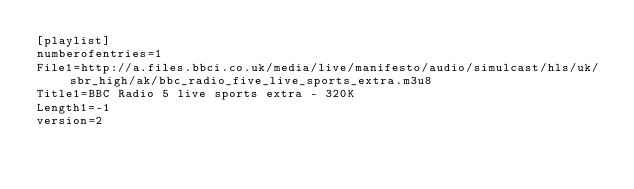Convert code to text. <code><loc_0><loc_0><loc_500><loc_500><_SQL_>[playlist]
numberofentries=1
File1=http://a.files.bbci.co.uk/media/live/manifesto/audio/simulcast/hls/uk/sbr_high/ak/bbc_radio_five_live_sports_extra.m3u8
Title1=BBC Radio 5 live sports extra - 320K
Length1=-1
version=2
</code> 